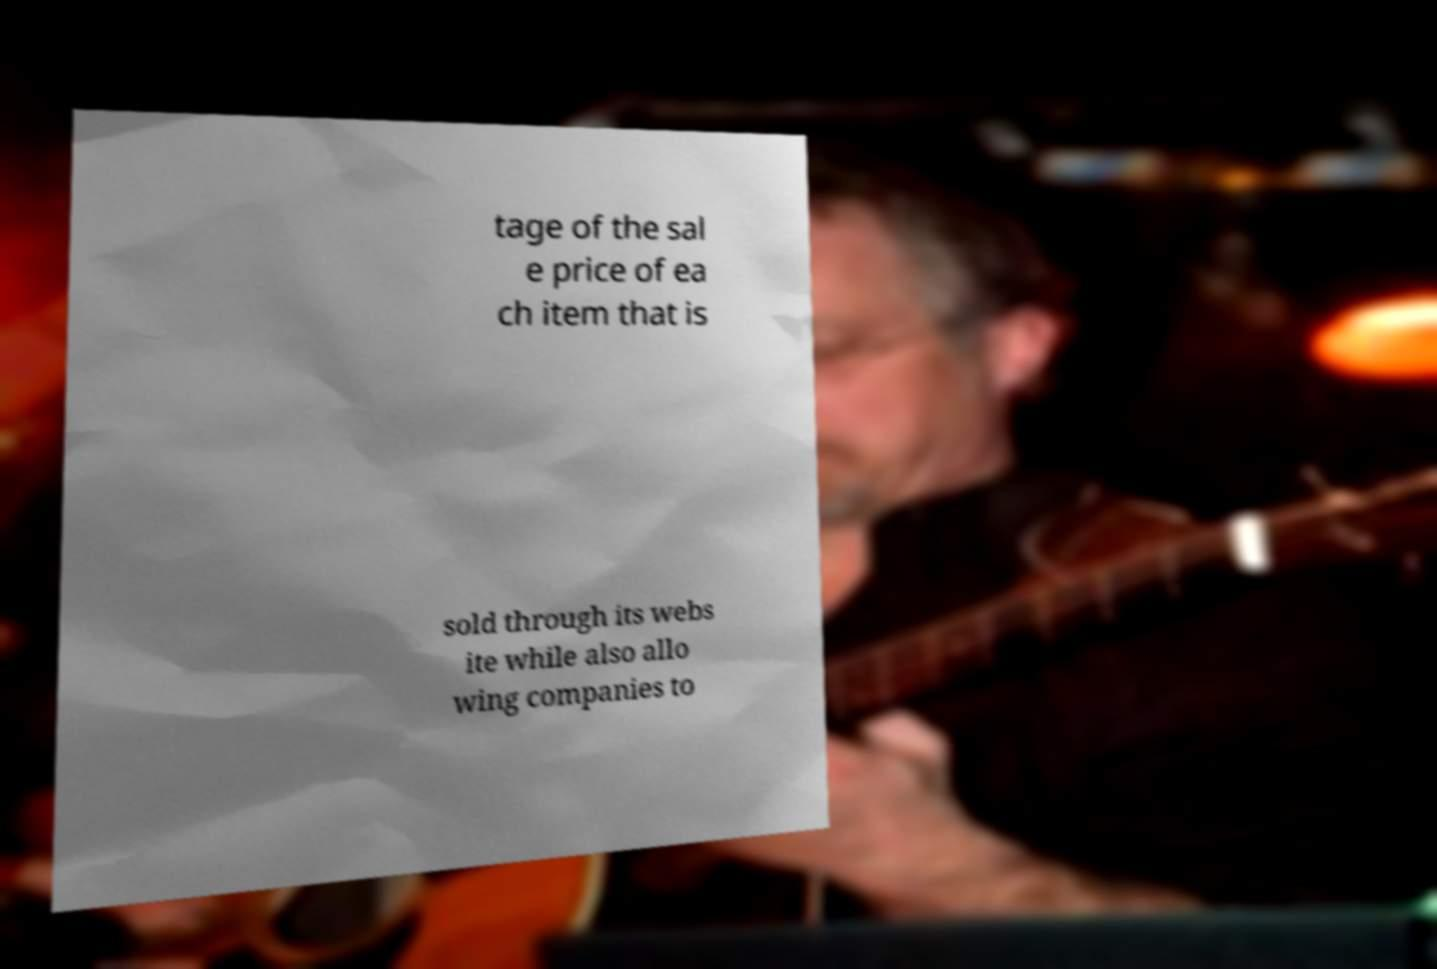Can you accurately transcribe the text from the provided image for me? tage of the sal e price of ea ch item that is sold through its webs ite while also allo wing companies to 